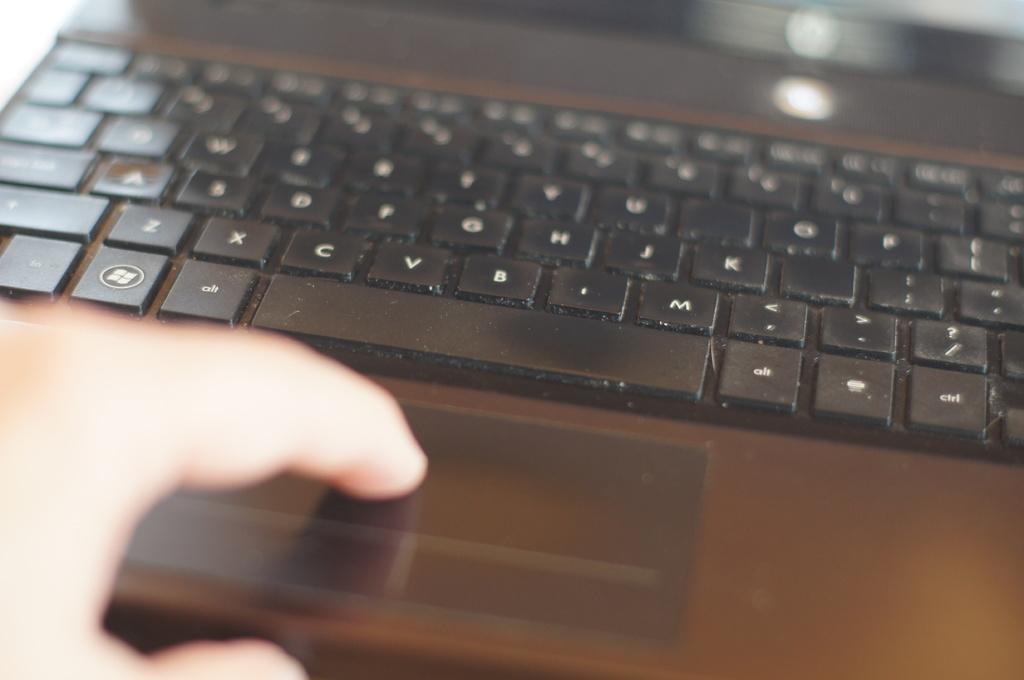What is to the left of the space bar?
Offer a very short reply. Alt. What button is left of the spacebar?
Provide a short and direct response. Alt. 